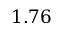Convert formula to latex. <formula><loc_0><loc_0><loc_500><loc_500>1 . 7 6</formula> 